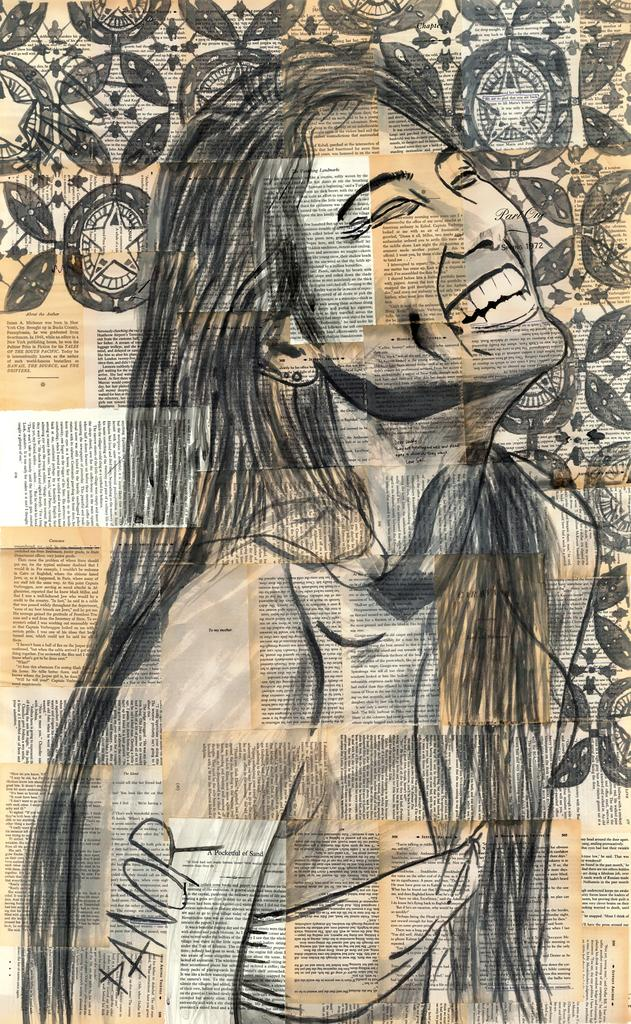<image>
Render a clear and concise summary of the photo. a drawing portrait of an Asian woman smiling with panor signing it. 